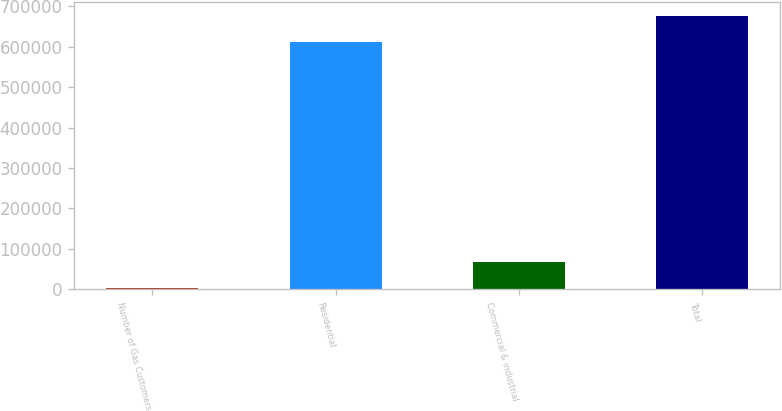Convert chart. <chart><loc_0><loc_0><loc_500><loc_500><bar_chart><fcel>Number of Gas Customers<fcel>Residential<fcel>Commercial & industrial<fcel>Total<nl><fcel>2012<fcel>610827<fcel>67316.3<fcel>676131<nl></chart> 